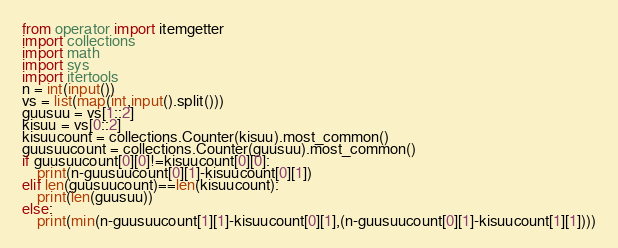<code> <loc_0><loc_0><loc_500><loc_500><_Python_>from operator import itemgetter
import collections
import math
import sys
import itertools
n = int(input())
vs = list(map(int,input().split()))
guusuu = vs[1::2]
kisuu = vs[0::2]
kisuucount = collections.Counter(kisuu).most_common()
guusuucount = collections.Counter(guusuu).most_common()
if guusuucount[0][0]!=kisuucount[0][0]:
    print(n-guusuucount[0][1]-kisuucount[0][1])
elif len(guusuucount)==len(kisuucount):
    print(len(guusuu))
else:
    print(min(n-guusuucount[1][1]-kisuucount[0][1],(n-guusuucount[0][1]-kisuucount[1][1])))</code> 